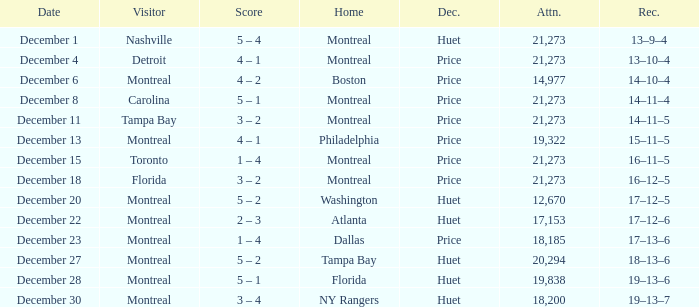What is the decision when the record is 13–10–4? Price. 